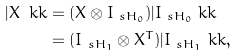Convert formula to latex. <formula><loc_0><loc_0><loc_500><loc_500>| X \ k k & = ( X \otimes I _ { \ s H _ { 0 } } ) | I _ { \ s H _ { 0 } } \ k k \\ & = ( I _ { \ s H _ { 1 } } \otimes X ^ { T } ) | I _ { \ s H _ { 1 } } \ k k ,</formula> 